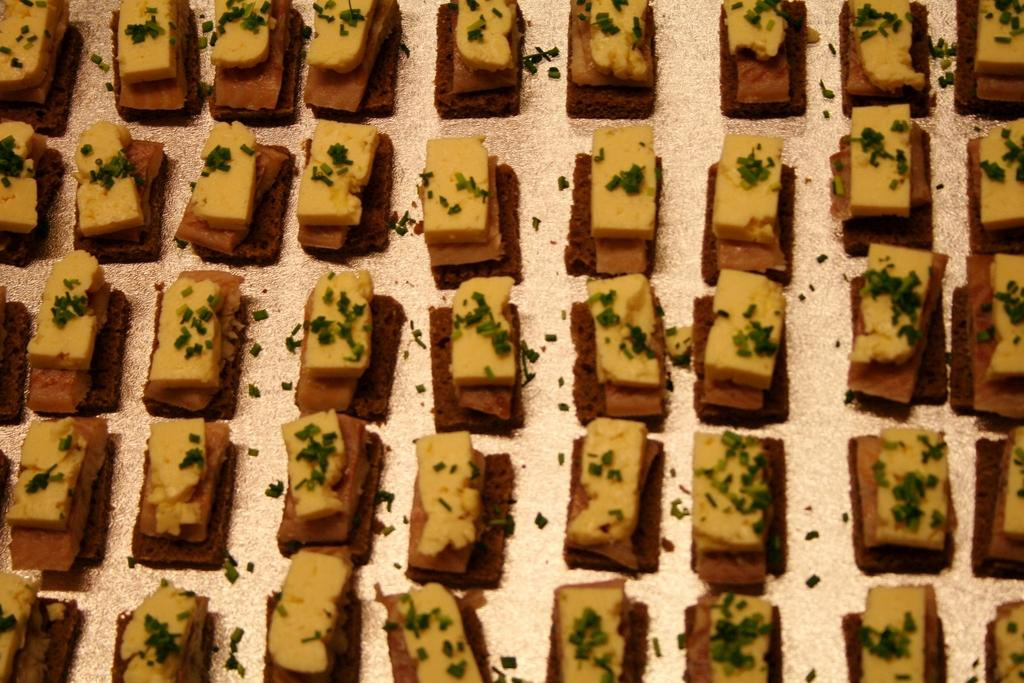What type of food items can be seen in the image? The food items resemble cakes. Can you describe the appearance of the cakes in the image? Unfortunately, the facts provided do not give any details about the appearance of the cakes. What type of vegetable is being used as a caption for the cakes in the image? There is no vegetable or caption present in the image. 